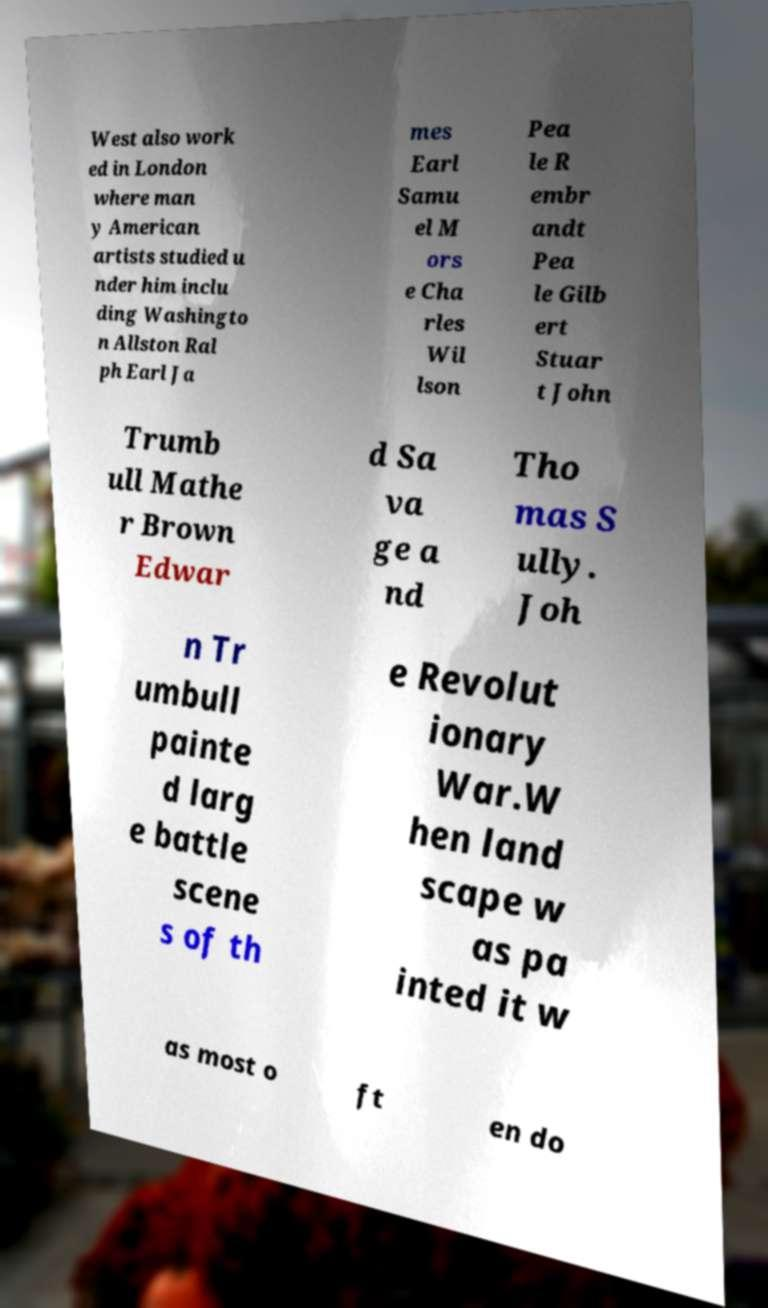Please identify and transcribe the text found in this image. West also work ed in London where man y American artists studied u nder him inclu ding Washingto n Allston Ral ph Earl Ja mes Earl Samu el M ors e Cha rles Wil lson Pea le R embr andt Pea le Gilb ert Stuar t John Trumb ull Mathe r Brown Edwar d Sa va ge a nd Tho mas S ully. Joh n Tr umbull painte d larg e battle scene s of th e Revolut ionary War.W hen land scape w as pa inted it w as most o ft en do 